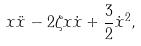<formula> <loc_0><loc_0><loc_500><loc_500>x \ddot { x } - 2 \zeta x \dot { x } + \frac { 3 } { 2 } \dot { x } ^ { 2 } ,</formula> 